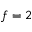Convert formula to latex. <formula><loc_0><loc_0><loc_500><loc_500>f = 2</formula> 